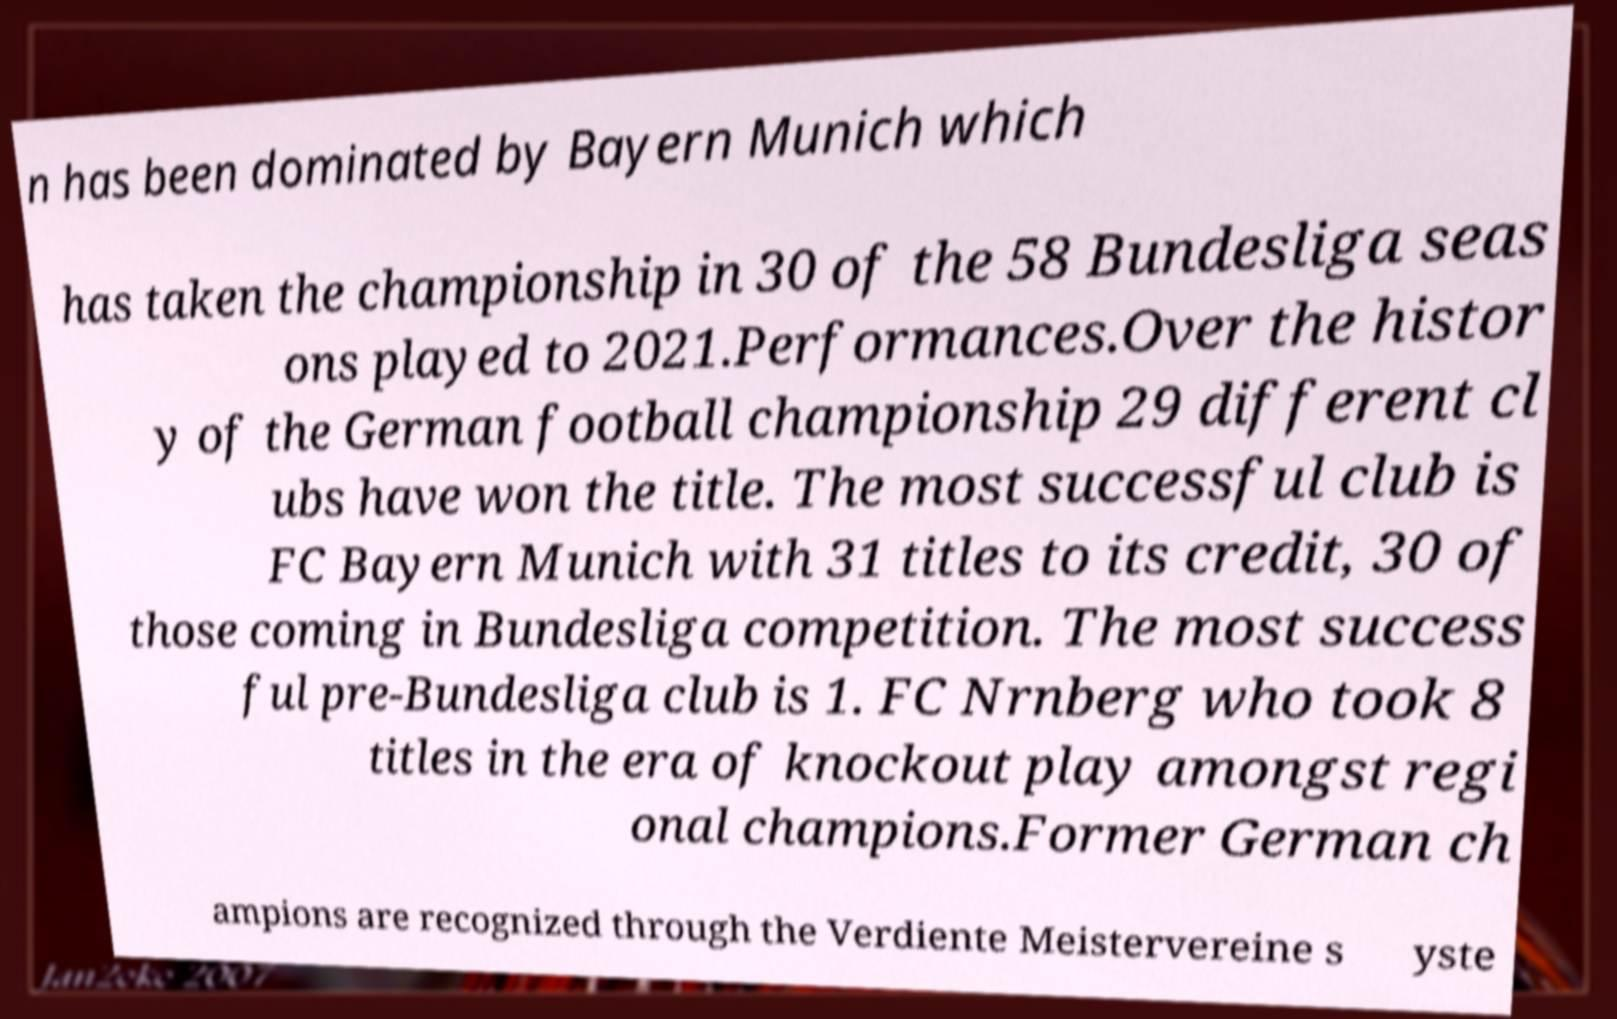Please identify and transcribe the text found in this image. n has been dominated by Bayern Munich which has taken the championship in 30 of the 58 Bundesliga seas ons played to 2021.Performances.Over the histor y of the German football championship 29 different cl ubs have won the title. The most successful club is FC Bayern Munich with 31 titles to its credit, 30 of those coming in Bundesliga competition. The most success ful pre-Bundesliga club is 1. FC Nrnberg who took 8 titles in the era of knockout play amongst regi onal champions.Former German ch ampions are recognized through the Verdiente Meistervereine s yste 